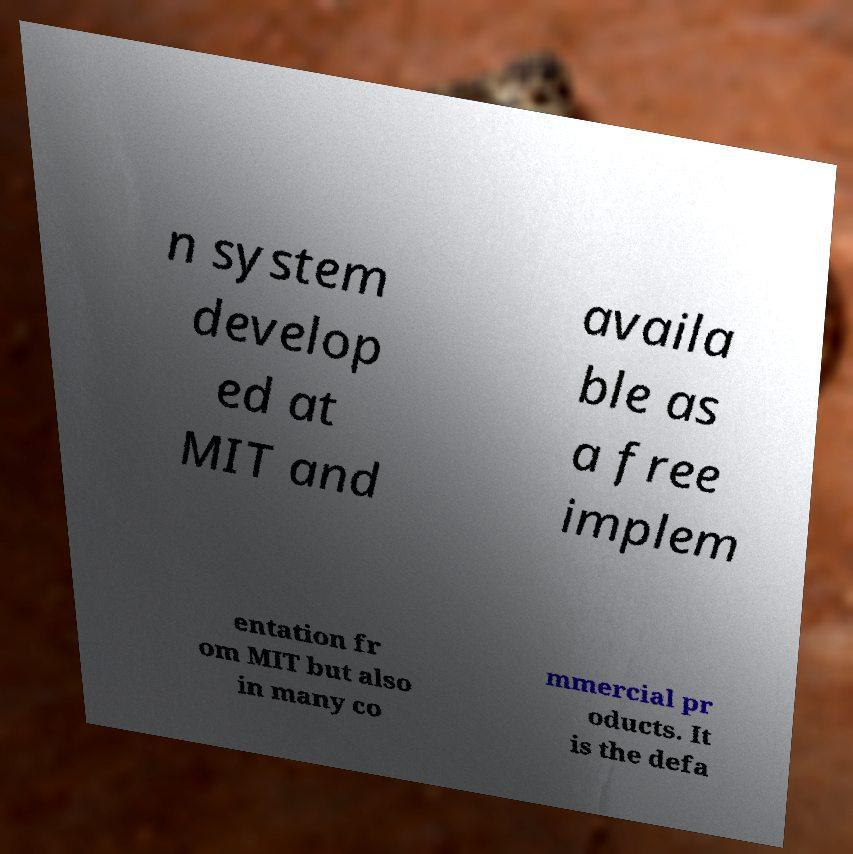What messages or text are displayed in this image? I need them in a readable, typed format. n system develop ed at MIT and availa ble as a free implem entation fr om MIT but also in many co mmercial pr oducts. It is the defa 